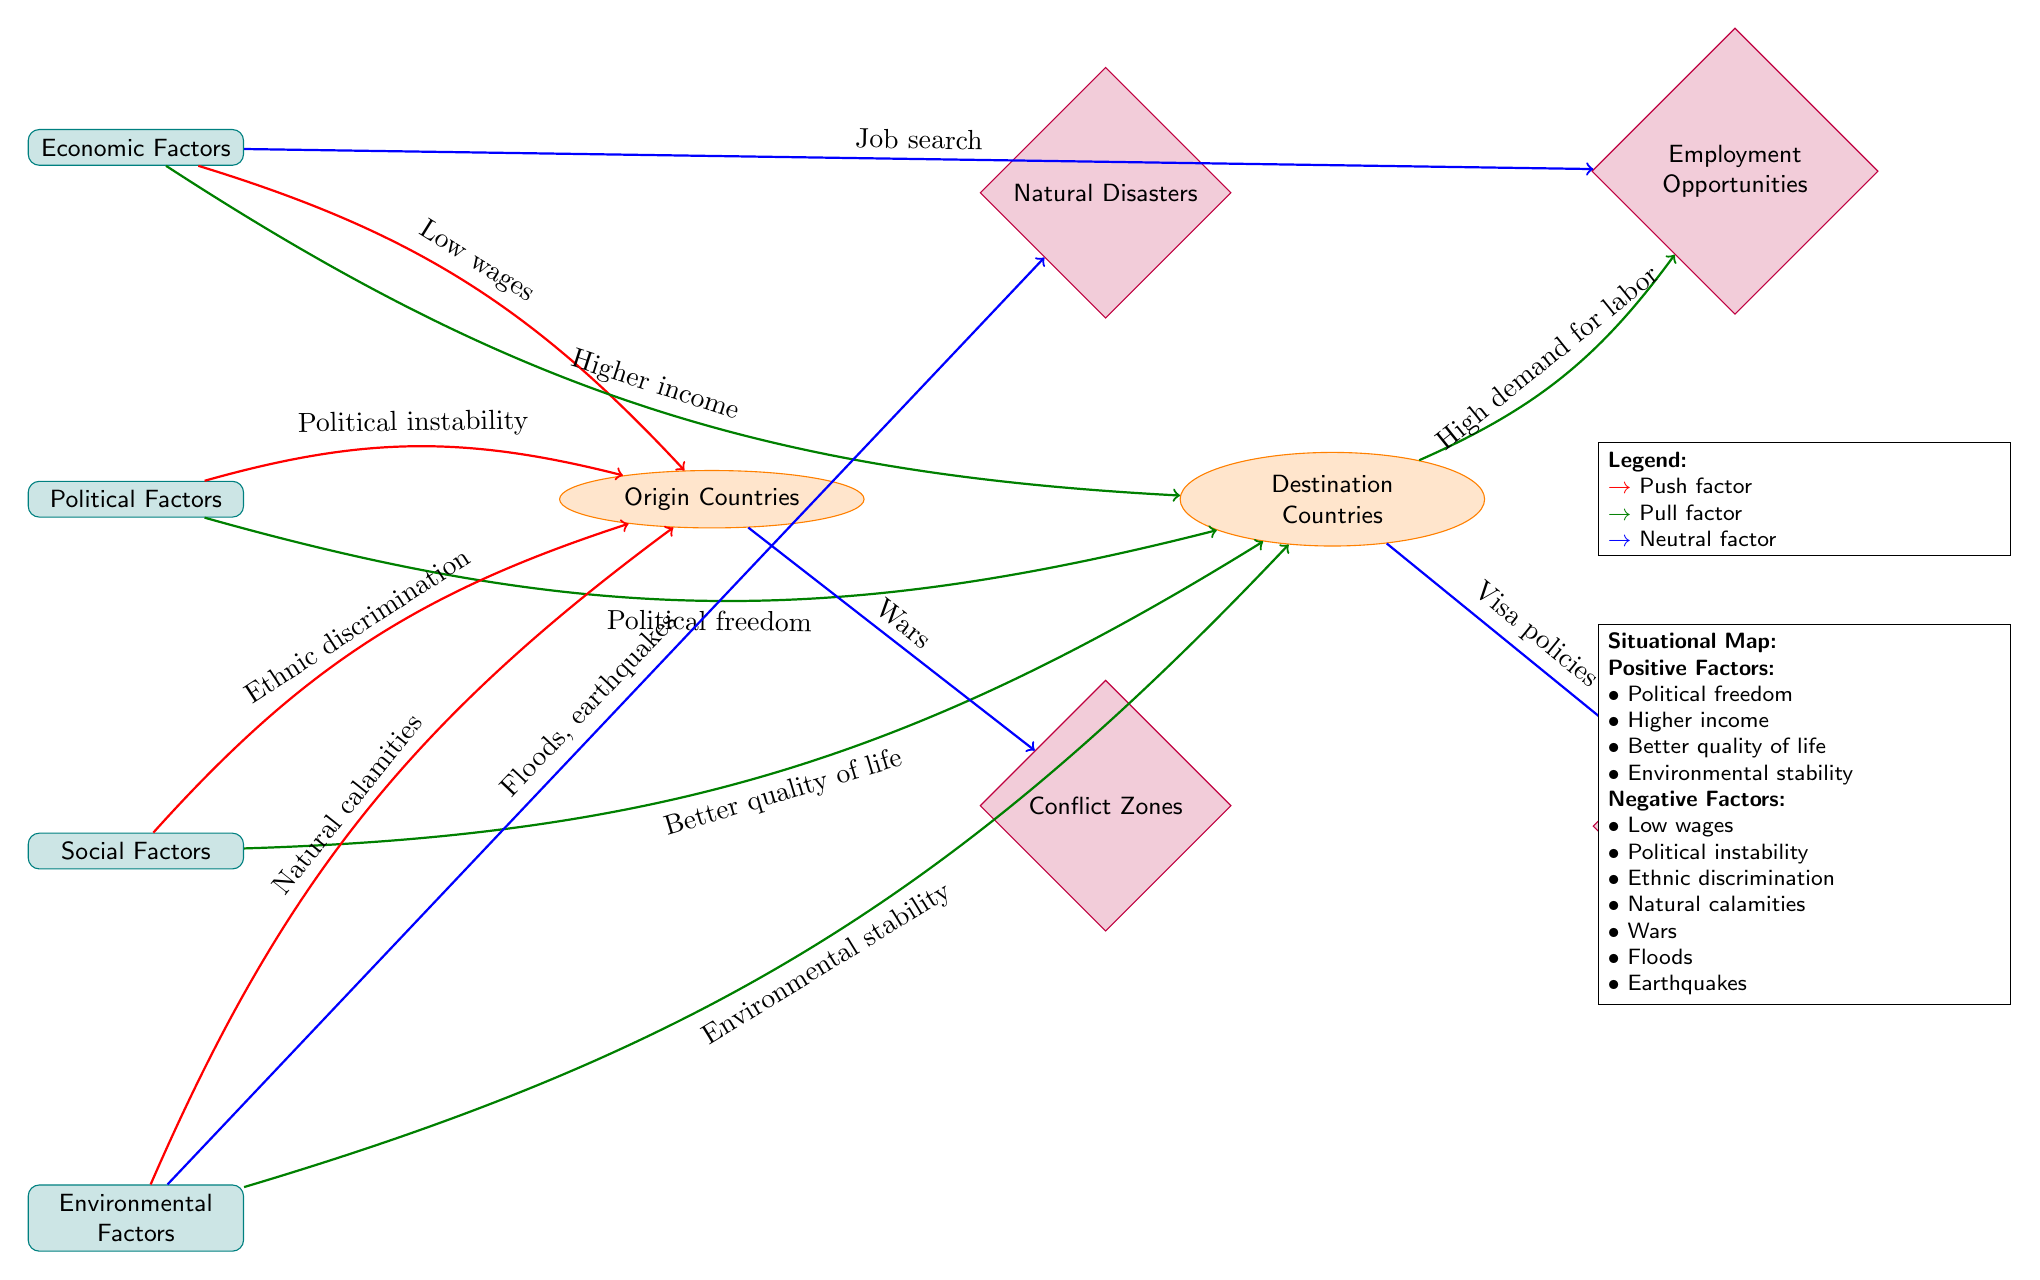What are the push factors highlighted in the diagram? The diagram lists four push factors: low wages, political instability, ethnic discrimination, and natural calamities. These factors can be identified by following the red arrows originating from the factor nodes that lead to the origin country node.
Answer: Low wages, political instability, ethnic discrimination, natural calamities How many pull factors are there in the diagram? In the diagram, there are four pull factors indicated by the green arrows leading to the destination country. They are higher income, political freedom, better quality of life, and environmental stability. Counting the pull factors gives a total of four.
Answer: 4 What type of factor is "wars" classified as? The label "Wars" is linked by a blue arrow from the origin country node to the conflict zones node, indicating that it is a neutral factor. Since the arrow is blue, it signifies no clear push or pull influence but rather a situational aspect.
Answer: Neutral factor What is the relationship between "Employment Opportunities" and "Higher income"? "Employment Opportunities" is a pull factor linked to "Higher income" through a green arrow which indicates that availability of employment can attract individuals by offering higher wages compared to their origin. This forms a direct relationship, where improved job prospects lead to higher income.
Answer: Pull factor relationship List one negative factor mentioned in the situational map. The situational map outlines several negative factors, including low wages, political instability, ethnic discrimination, natural calamities, wars, floods, and earthquakes. Any of these can be accepted, but "low wages" is a straightforward initial answer. It is directly listed under negative factors.
Answer: Low wages What is the main category of factors influencing movement to the destination countries? The main category influencing movement represented in the diagram is economic factors, which is the top node in the flowchart. The term "economic factors" appears prominently, connecting to both push and pull dynamics affecting migration.
Answer: Economic Factors Which factor primarily indicates the need for migration due to health or safety concerns? "Natural calamities" under environmental factors indicates a significant reason for migration due to health or safety issues. This push factor is represented by a red arrow pointing towards the origin node. Therefore, it highlights a compelling case for people to leave their homes.
Answer: Natural calamities How does "Visa policies" relate to migration according to the diagram? "Visa policies" is situated as a neutral factor associated with the destination countries. It is connected by a blue arrow implying that while it does not explicitly push or pull individuals, it plays a crucial role in determining migration feasibility and access to opportunities in destination countries.
Answer: Neutral factor What does the arrow's color indicating "Higher income" suggest in terms of migration? The arrow indicating "Higher income" is green, which represents a pull factor in the context of migration. This suggests that higher potential income attracts individuals to move towards destination countries in search of better financial opportunities.
Answer: Pull factor 